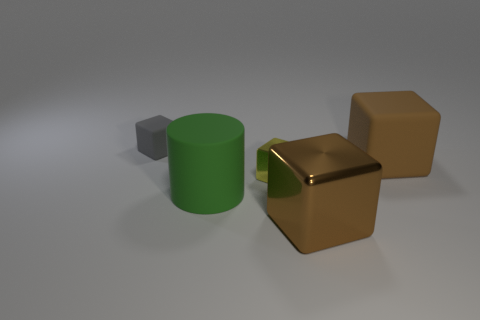Are there any matte objects of the same color as the big metallic thing?
Keep it short and to the point. Yes. There is another object that is the same color as the large shiny object; what is its material?
Give a very brief answer. Rubber. How many metallic blocks are the same size as the rubber cylinder?
Your response must be concise. 1. What number of shiny things are large green objects or tiny yellow cubes?
Ensure brevity in your answer.  1. What is the material of the yellow block?
Offer a terse response. Metal. What number of brown things are behind the big matte cube?
Keep it short and to the point. 0. Are the brown object in front of the big cylinder and the yellow thing made of the same material?
Keep it short and to the point. Yes. How many small objects are the same shape as the big green thing?
Provide a succinct answer. 0. How many small objects are yellow cubes or brown metal things?
Provide a succinct answer. 1. There is a rubber block that is to the left of the big metal cube; is its color the same as the small metallic thing?
Your answer should be very brief. No. 